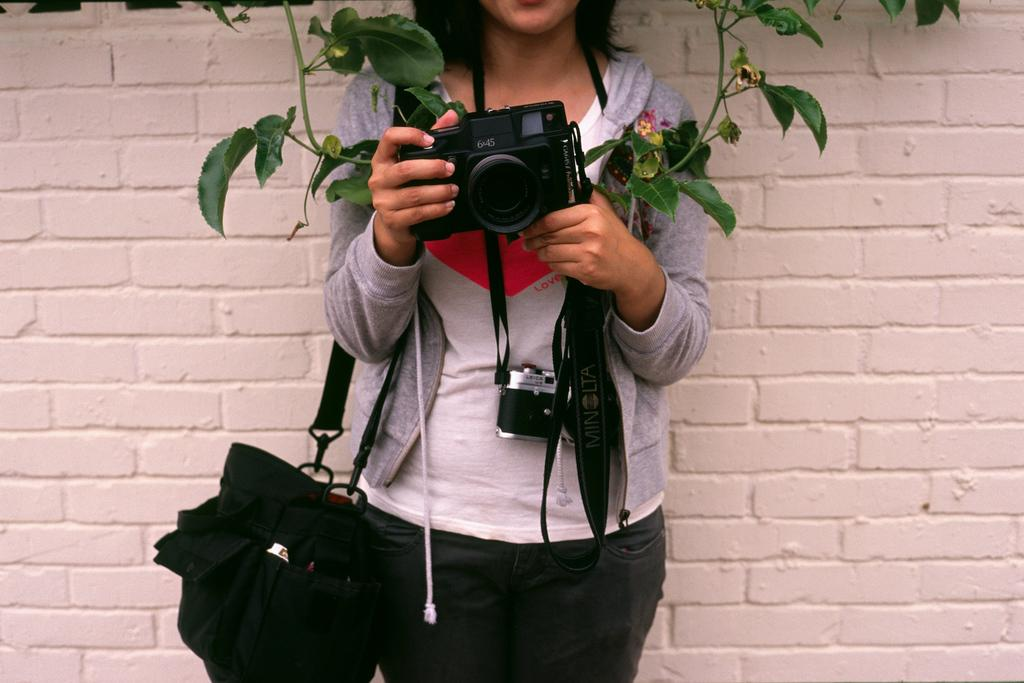Who is the main subject in the image? There is a woman in the image. What is the woman doing in the image? The woman is standing and holding a camera. What can be seen in the background of the image? There is a plant and a wall in the background of the image. What type of spark can be seen coming from the camera in the image? There is no spark visible in the image; the woman is simply holding a camera. 